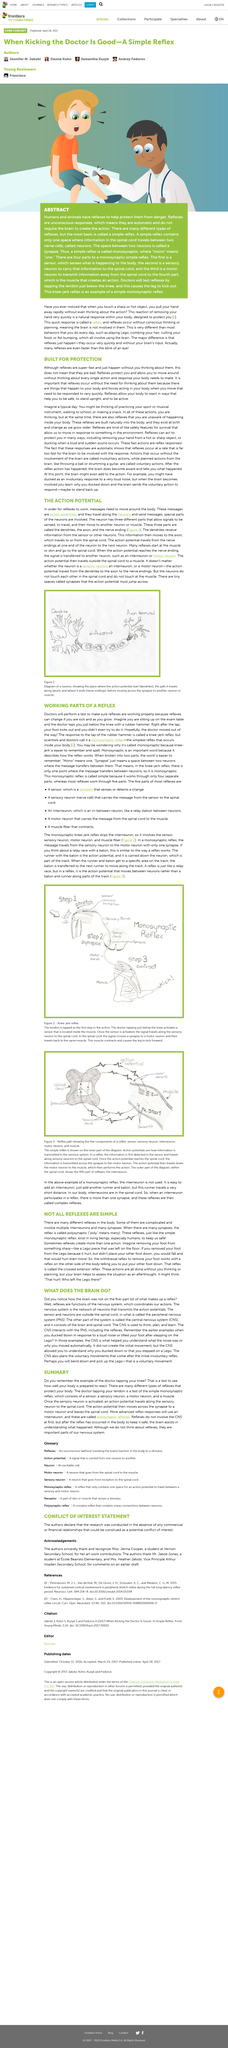Outline some significant characteristics in this image. Action potential messages travel along neurons. Reflexes are the functions of the nervous system that coordinate our actions, and they are a crucial part of the body's ability to respond to stimuli in the environment. The axon connects the dendrite and the axon terminal. The figure 1 depicts a neuron, which is a diagram of it. The peripheral nervous system consists of sensors and neurons located outside the spinal cord. 